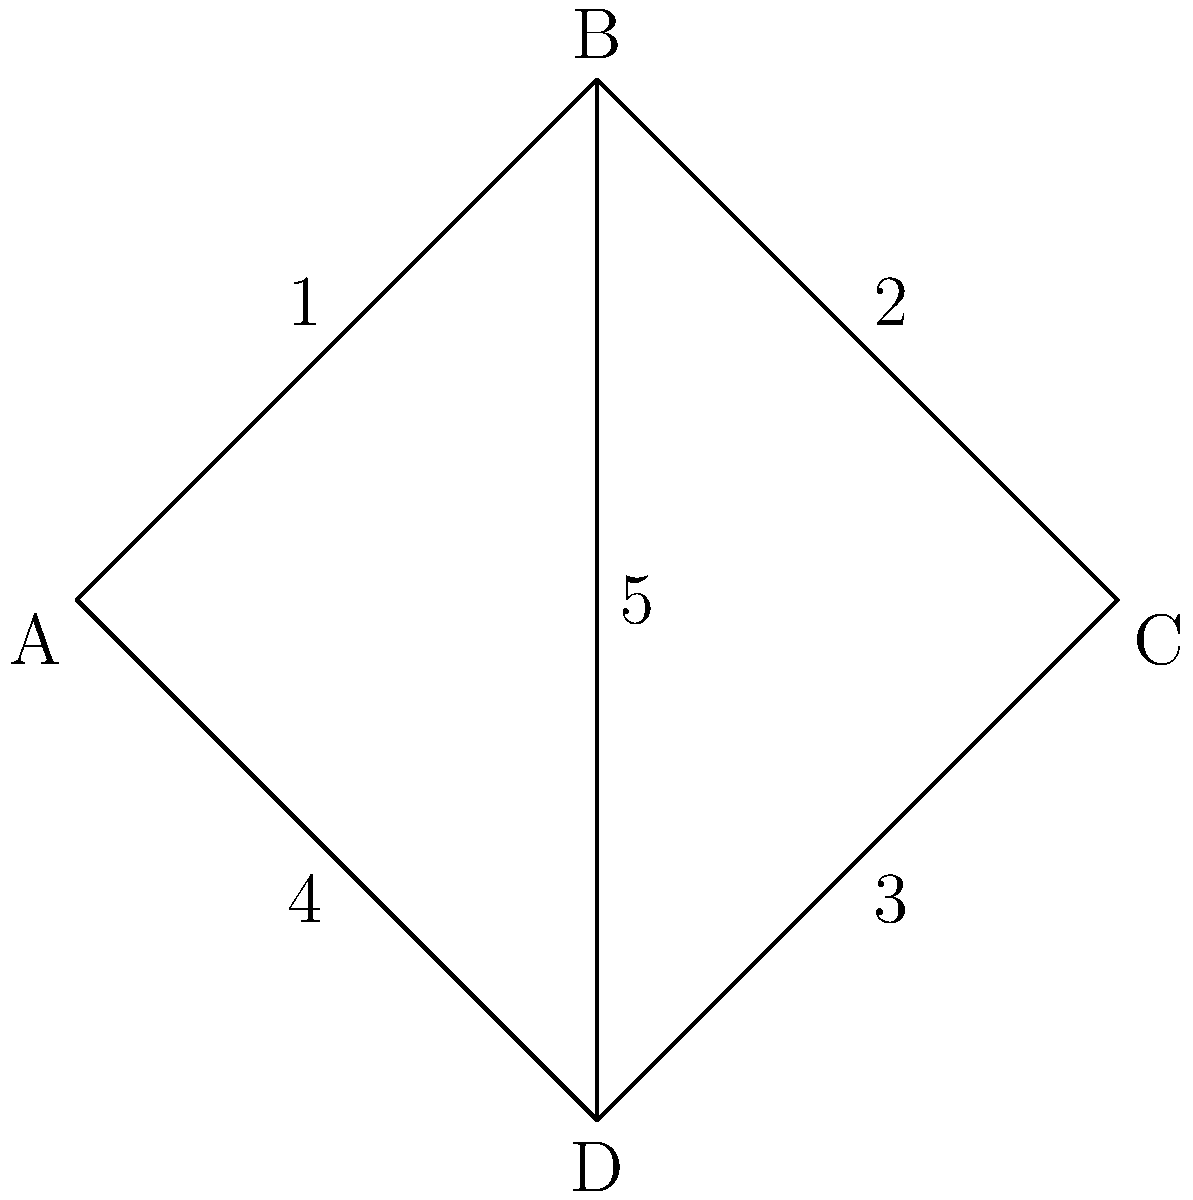In the context of network topology diagrams used in legal proceedings, consider the diagram above representing a company's network infrastructure. If node B is compromised, leading to a data breach, and the company failed to implement the industry-standard security measure of encrypting data transfers on edges with weights greater than 3, which specific connection(s) could potentially lead to legal liability for the company? Provide your answer using the node labels. To answer this question, we need to follow these steps:

1. Identify the edges with weights greater than 3:
   - Edge B-D has a weight of 5

2. Determine which of these edges are connected to the compromised node B:
   - The edge B-D is connected to node B

3. Consider the legal implications:
   - Failure to encrypt data transfers on high-weight edges (representing important or high-volume data transfers) could be seen as negligence
   - If the company didn't encrypt this connection and it led to a data breach, they could be held liable

4. Formulate the answer:
   - The connection B-D is the only one that meets all criteria (weight > 3, connected to compromised node B)

Therefore, the specific connection that could potentially lead to legal liability for the company is B-D.
Answer: B-D 